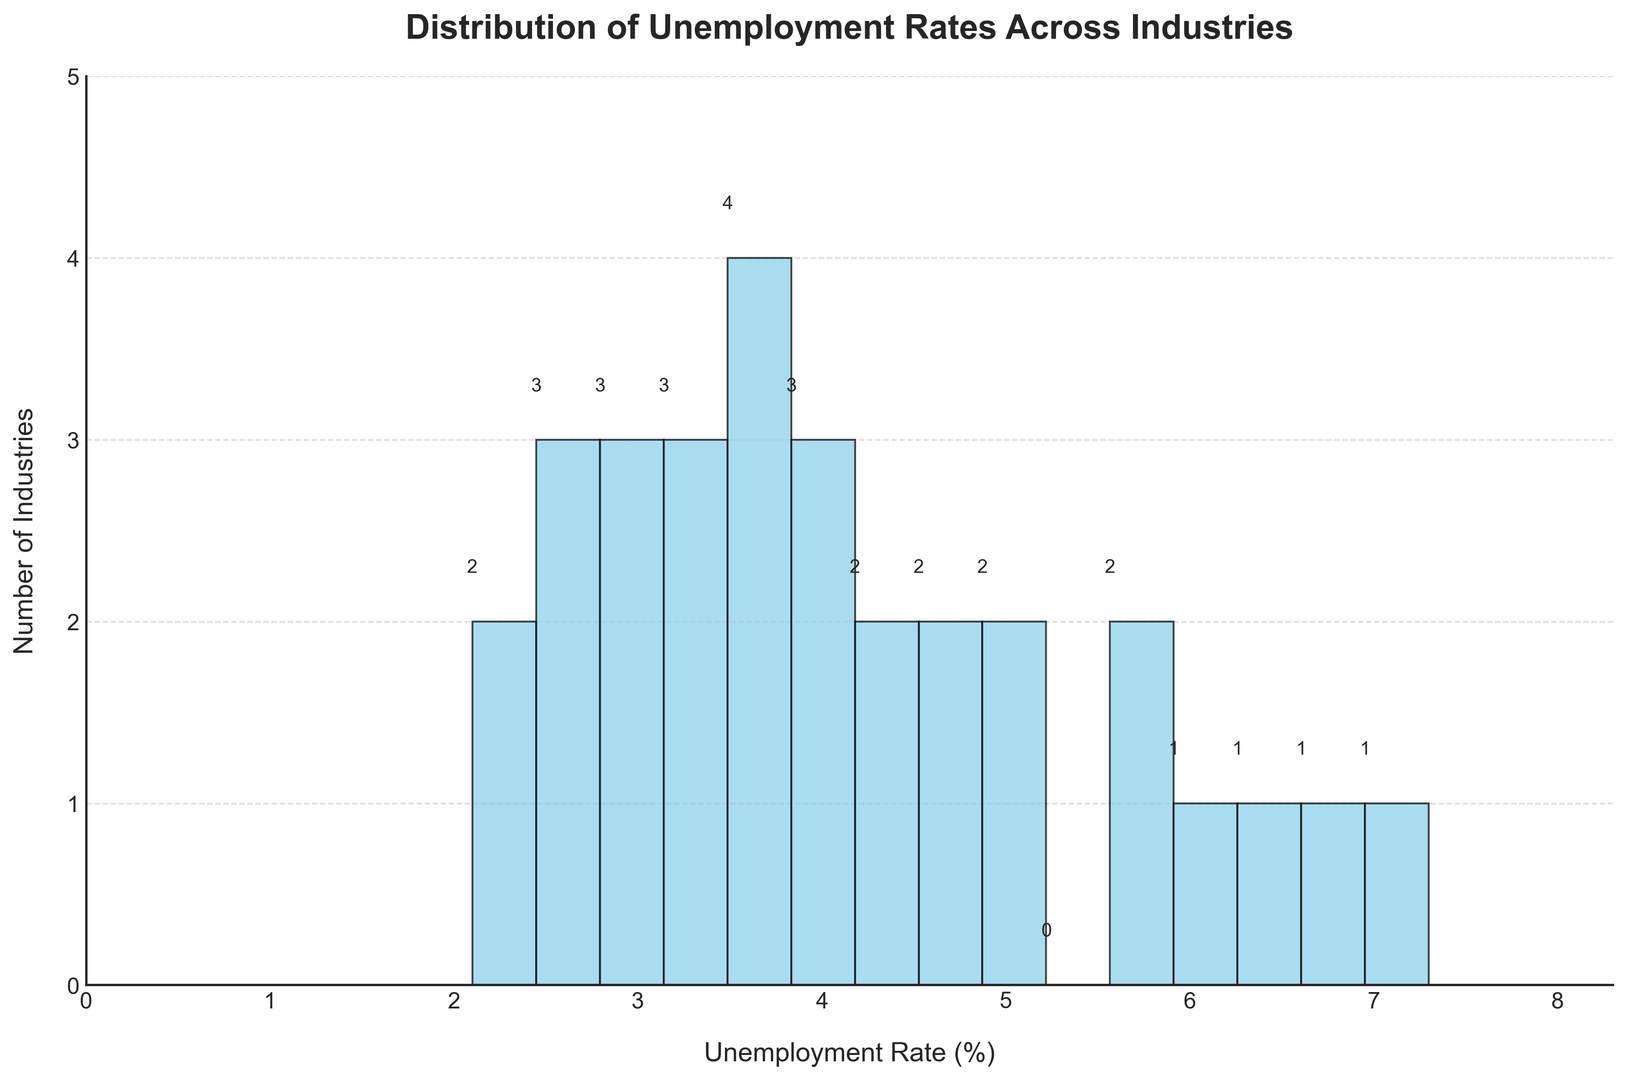How many industries have an unemployment rate between 2% and 4%? To determine this, count the number of bars in the histogram that fall between the ranges 2% and 4%. These include the bars for 2%-2.5%, 2.5%-3%, 3%-3.5%, and 3.5%-4%.
Answer: 13 Which industry has the highest unemployment rate? Identify the industry associated with the bar that extends the furthest to the right.
Answer: Arts and Entertainment What is the most common unemployment rate range among the industries? Find the tallest bar in the histogram, which represents the range with the most industries.
Answer: 3%-3.5% How does the number of industries with an unemployment rate above 5% compare to those with a rate below 3%? Count the bars representing unemployment rates above 5%, then count the bars representing rates below 3%, and compare the two counts. Above 5% includes 5%-5.5%, 5.5%-6%, 6%-6.5%,... . Below 3% includes 2%-2.5%, 2.5%-3%.
Answer: Above 5%: 6, Below 3%: 5 What percentage of industries have an unemployment rate between 3% and 5%? To calculate this, count the number of industries with unemployment rates between 3% and 5% and divide by the total number of industries, then multiply by 100. The percentage of industries between 3% and 5% includes 3%-3.5%, 3.5%-4%, 4%-4.5%, 4.5%-5%. There are 12 such industries out of 29.
Answer: 41.4% Which unemployment rate range has the second highest number of industries? After visually identifying the range with the most industries (3%-3.5%), look for the next tallest bar to find the second most common range.
Answer: 2.5%-3% In which range do you see the smallest number of industries? Identify the range with the shortest bar in the histogram.
Answer: 6.5%-7% How does the count of industries with an unemployment rate under 4% compare visually to those with unemployment rates between 4% and 6%? Count the bars representing unemployment rates under 4% (2%-2.5%, 2.5%-3%, 3%-3.5%, 3.5%-4%) and those between 4% and 6% (4%-4.5%, 4.5%-5%, 5%-5.5%, 5.5%-6%). Compare these counts.
Answer: Under 4%: 14, Between 4%-6%: 7 What does the height of the tallest bar suggest about the distribution of unemployment rates? The height of the tallest bar suggests that a particular unemployment rate range encompasses the largest number of industries, indicating a common unemployment rate.
Answer: Most common rate: 3%-3.5% What can you infer about the unemployment rates in Finance and Healthcare compared to the average? Calculate the approximate average unemployment rate visually from the histogram, then compare individual rates for Finance (2.6%) and Healthcare (2.1%) to this average. From the histogram, the bulk of unemployment rates seem to be centered around 3%-4%.
Answer: Below average 